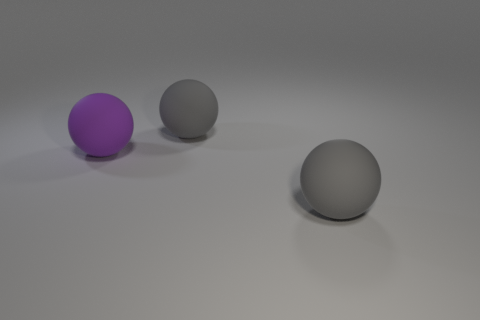Subtract all gray spheres. How many spheres are left? 1 Subtract 3 balls. How many balls are left? 0 Subtract all purple balls. How many balls are left? 2 Add 2 gray spheres. How many objects exist? 5 Subtract all red cylinders. How many brown spheres are left? 0 Subtract all blue balls. Subtract all red cubes. How many balls are left? 3 Subtract all large balls. Subtract all large red matte objects. How many objects are left? 0 Add 3 big balls. How many big balls are left? 6 Add 1 gray matte spheres. How many gray matte spheres exist? 3 Subtract 0 cyan cubes. How many objects are left? 3 